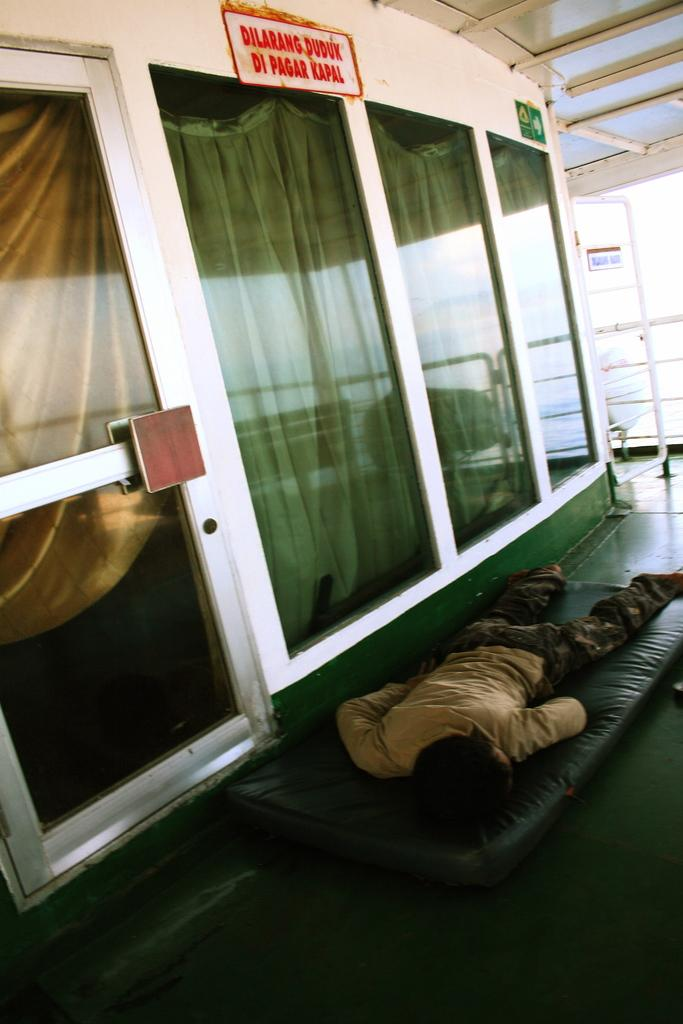What type of objects can be seen in the image? There are boards, a door, a floor carpet, and a glass in the image. What is the person in the image doing? A person is sleeping on a bed in the image. What might be used to cover the windows in the image? Curtains are visible through the glass in the image. What type of ornament is hanging from the ceiling in the image? There is no ornament hanging from the ceiling in the image. What memories might the person in the image be recalling while sleeping? The image does not provide any information about the person's memories or thoughts while sleeping. 